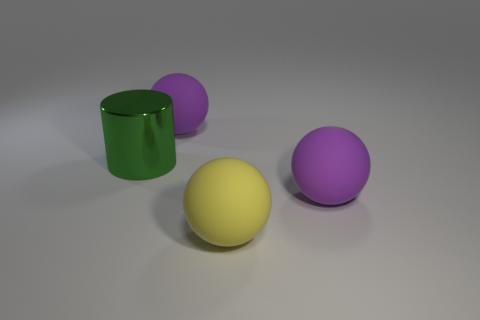Is the shape of the yellow object that is in front of the shiny cylinder the same as  the green object?
Ensure brevity in your answer.  No. There is a big green object that is behind the big yellow matte ball; what is its material?
Offer a very short reply. Metal. How many big purple matte objects have the same shape as the yellow object?
Offer a very short reply. 2. There is a large thing that is on the left side of the matte ball that is behind the cylinder; what is it made of?
Offer a very short reply. Metal. Are there any big purple spheres made of the same material as the big yellow sphere?
Provide a succinct answer. Yes. What is the shape of the metal thing?
Offer a terse response. Cylinder. How many balls are there?
Make the answer very short. 3. What is the color of the sphere in front of the big object that is to the right of the yellow ball?
Ensure brevity in your answer.  Yellow. There is a metallic cylinder that is the same size as the yellow rubber sphere; what color is it?
Ensure brevity in your answer.  Green. Is there a large purple ball?
Provide a succinct answer. Yes. 